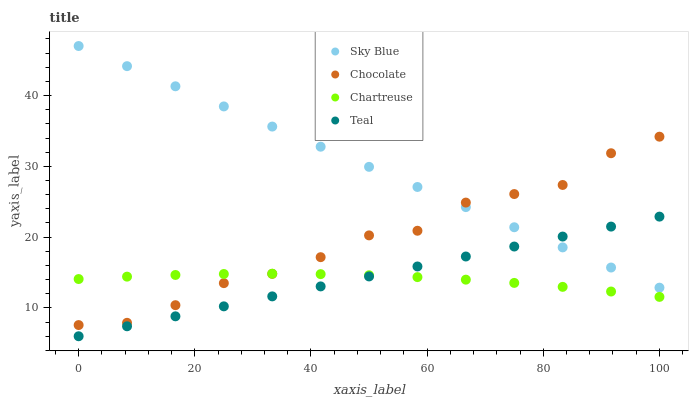Does Chartreuse have the minimum area under the curve?
Answer yes or no. Yes. Does Sky Blue have the maximum area under the curve?
Answer yes or no. Yes. Does Teal have the minimum area under the curve?
Answer yes or no. No. Does Teal have the maximum area under the curve?
Answer yes or no. No. Is Teal the smoothest?
Answer yes or no. Yes. Is Chocolate the roughest?
Answer yes or no. Yes. Is Chartreuse the smoothest?
Answer yes or no. No. Is Chartreuse the roughest?
Answer yes or no. No. Does Teal have the lowest value?
Answer yes or no. Yes. Does Chartreuse have the lowest value?
Answer yes or no. No. Does Sky Blue have the highest value?
Answer yes or no. Yes. Does Teal have the highest value?
Answer yes or no. No. Is Chartreuse less than Sky Blue?
Answer yes or no. Yes. Is Sky Blue greater than Chartreuse?
Answer yes or no. Yes. Does Sky Blue intersect Teal?
Answer yes or no. Yes. Is Sky Blue less than Teal?
Answer yes or no. No. Is Sky Blue greater than Teal?
Answer yes or no. No. Does Chartreuse intersect Sky Blue?
Answer yes or no. No. 